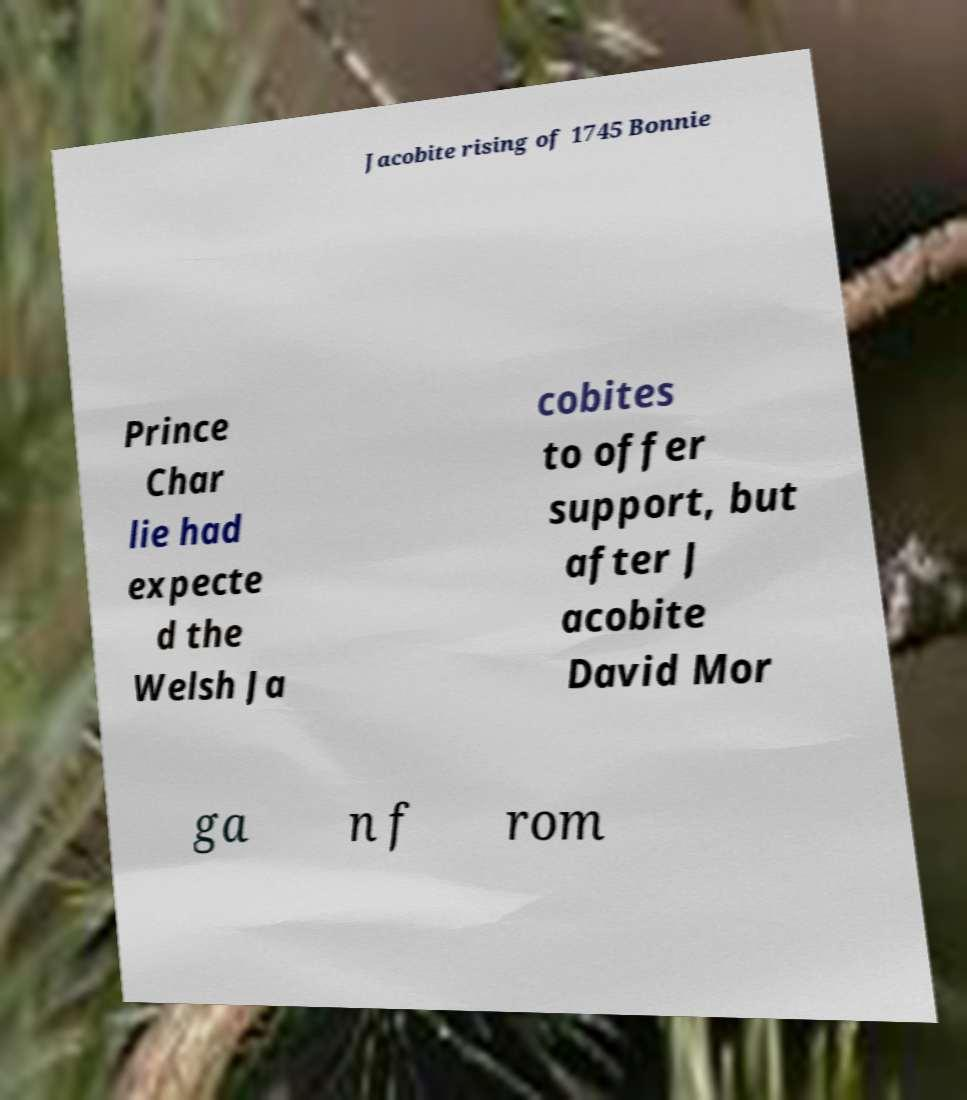Please identify and transcribe the text found in this image. Jacobite rising of 1745 Bonnie Prince Char lie had expecte d the Welsh Ja cobites to offer support, but after J acobite David Mor ga n f rom 